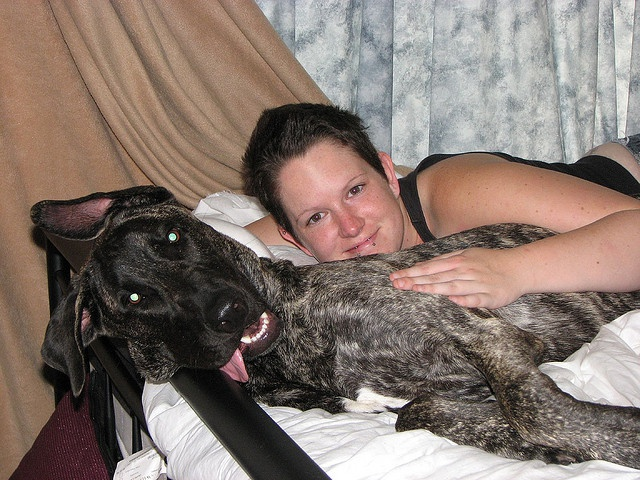Describe the objects in this image and their specific colors. I can see dog in gray, black, and darkgray tones, people in gray, salmon, and black tones, and bed in gray, lightgray, black, and darkgray tones in this image. 